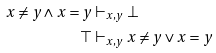<formula> <loc_0><loc_0><loc_500><loc_500>x \neq y \wedge x = y & \vdash _ { x , y } \bot \\ \top & \vdash _ { x , y } x \neq y \vee x = y</formula> 